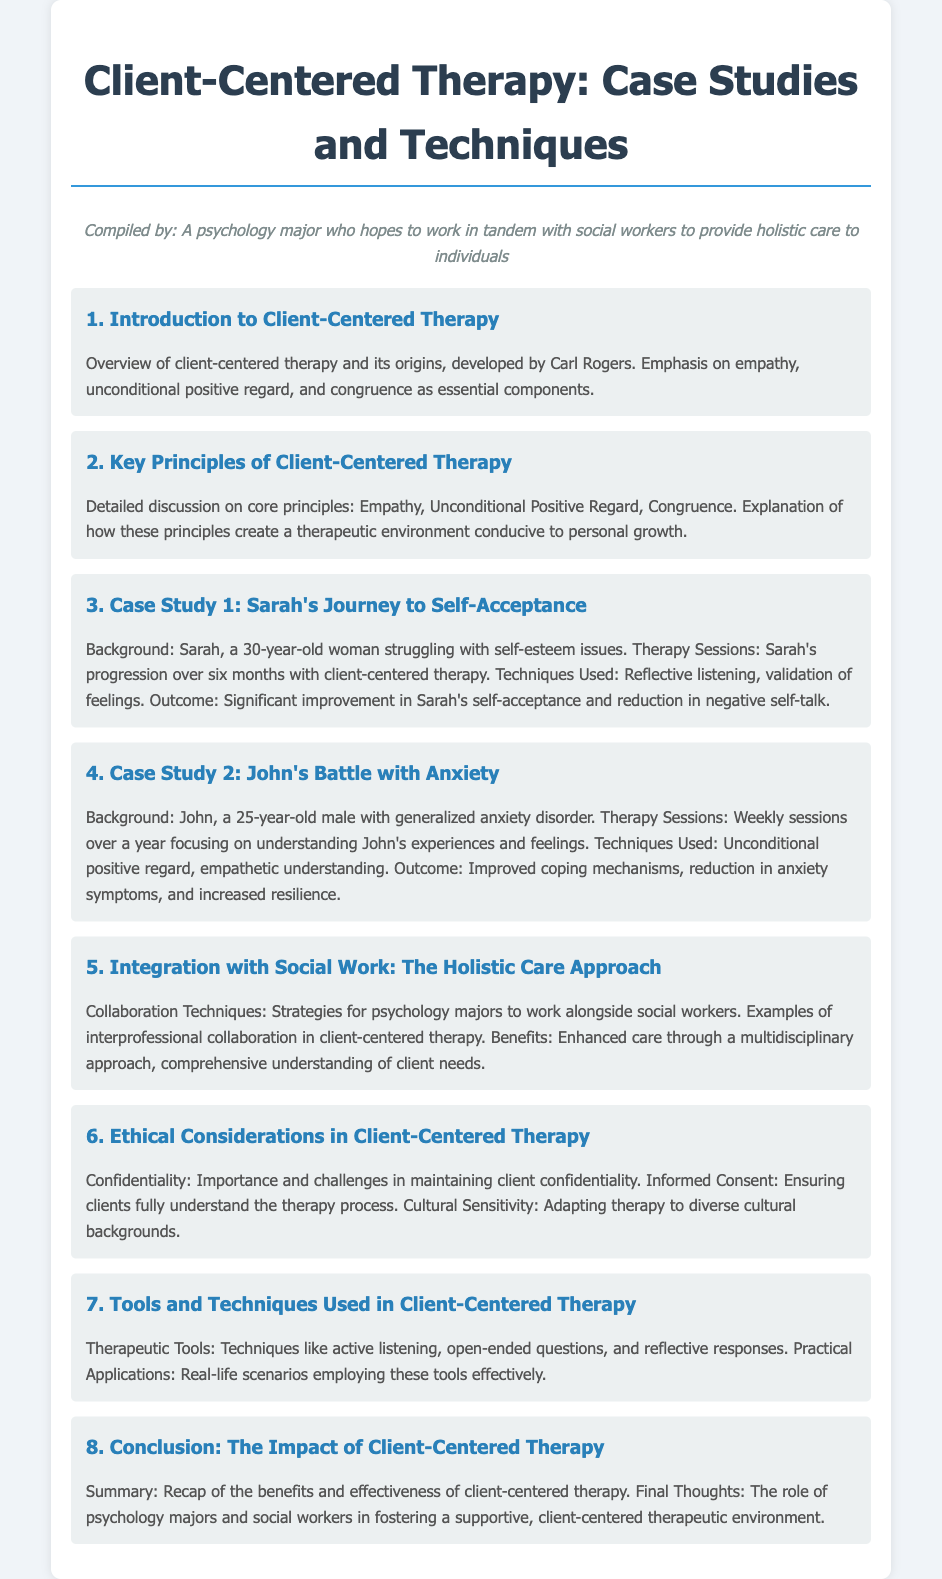What is the title of the document? The title appears at the top of the rendered document, summarizing its focus on client-centered therapy case studies and techniques.
Answer: Client-Centered Therapy: Case Studies and Techniques Who developed client-centered therapy? The document mentions Carl Rogers as the developer of client-centered therapy in the introduction section.
Answer: Carl Rogers What key principle emphasizes acceptance in client-centered therapy? The key principle that focuses on acceptance is explained in the section on key principles of client-centered therapy.
Answer: Unconditional Positive Regard How many case studies are presented in the document? The number of case studies can be found by counting the sections dedicated to case studies within the document.
Answer: Two What is the outcome for Sarah in Case Study 1? The outcome is described in terms of specific improvements Sarah experienced after therapy sessions.
Answer: Significant improvement in self-acceptance In which section does it discuss collaboration techniques with social workers? The document includes a section that specifically addresses collaboration techniques between psychology majors and social workers.
Answer: Integration with Social Work: The Holistic Care Approach What ethical consideration is mentioned related to maintaining confidentiality? The document states various ethical considerations, including one that relates to maintaining client confidentiality in therapy.
Answer: Confidentiality What therapeutic tool is listed in the tools and techniques section? The document identifies various tools and techniques effective in client-centered therapy, with one being specifically highlighted.
Answer: Active listening 